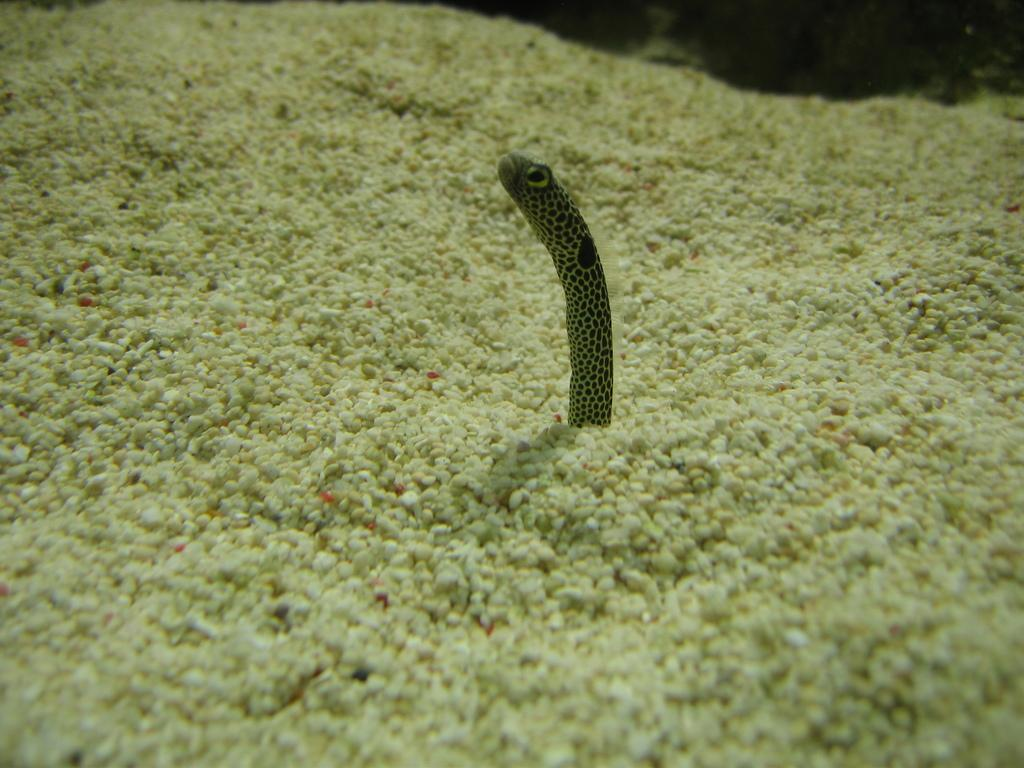What type of objects can be seen in the image? There are stones in the image. What is the main subject of the image? There is an animal in the center of the image. How much money is the animal holding in the image? There is no money present in the image, and the animal is not holding anything. What type of creature is the animal in the image? The provided facts do not specify the type of animal, so we cannot determine the creature's classification from the image. 